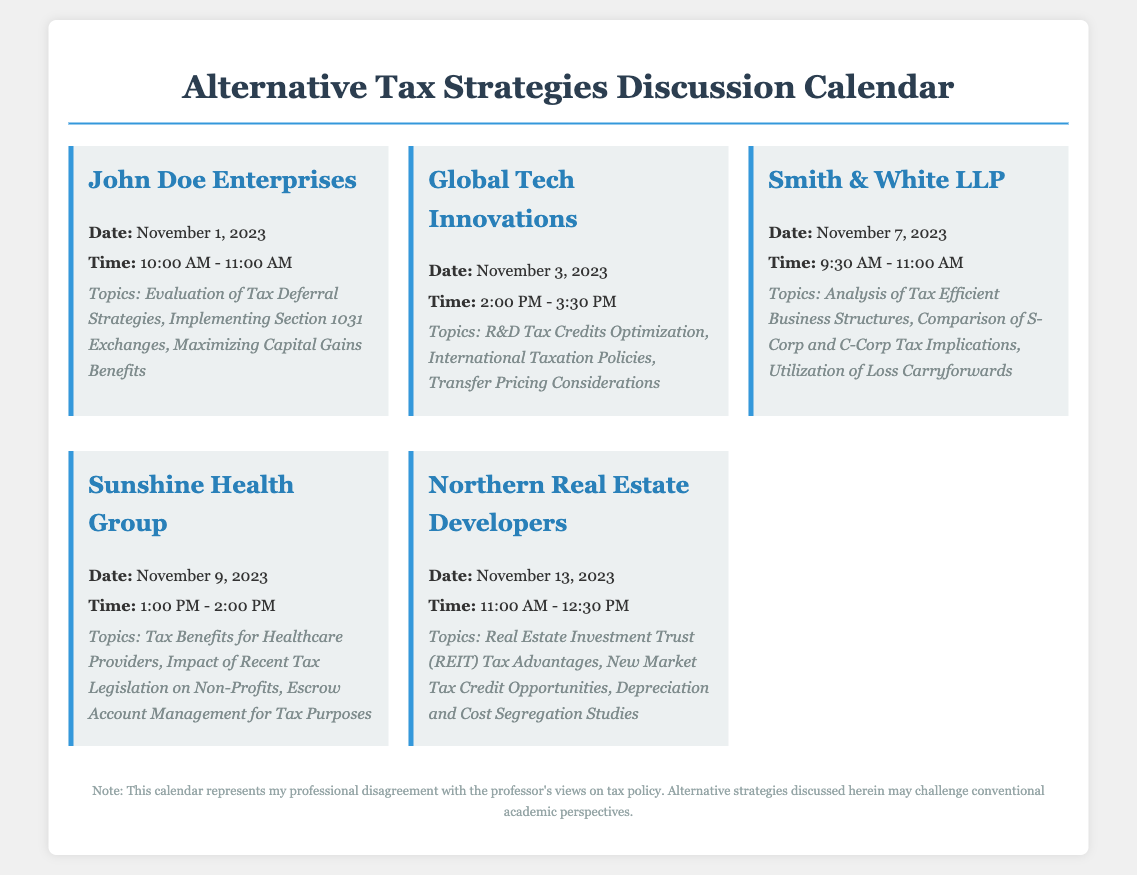What is the date of the meeting with John Doe Enterprises? The document provides specific dates for each meeting, and John Doe Enterprises is scheduled for November 1, 2023.
Answer: November 1, 2023 What time is the meeting with Global Tech Innovations? The time for the Global Tech Innovations meeting is detailed in the document, which is from 2:00 PM to 3:30 PM.
Answer: 2:00 PM - 3:30 PM Which company is discussing tax benefits for healthcare providers? The document lists various meetings and their topics, indicating that Sunshine Health Group is focusing on tax benefits for healthcare providers.
Answer: Sunshine Health Group What are the topics discussed in the meeting with Smith & White LLP? The meeting information contains a detailed list of topics to be discussed with Smith & White LLP, which includes analysis of tax-efficient structures, among others.
Answer: Analysis of Tax Efficient Business Structures, Comparison of S-Corp and C-Corp Tax Implications, Utilization of Loss Carryforwards How long is the meeting with Northern Real Estate Developers? The duration of the meeting is given as 1 hour and 30 minutes, running from 11:00 AM to 12:30 PM.
Answer: 1 hour and 30 minutes What is the main focus of the meeting scheduled for November 9, 2023? The main focus is specified in the topics, detailing tax benefits for healthcare providers and the impact of legislation on non-profits.
Answer: Tax Benefits for Healthcare Providers What is the disclaimer about in the document? The disclaimer indicates that the calendar represents a disagreement with the professor's views on tax policy and addresses alternative strategies that challenge conventional perspectives.
Answer: Disagreement with the professor's views on tax policy 